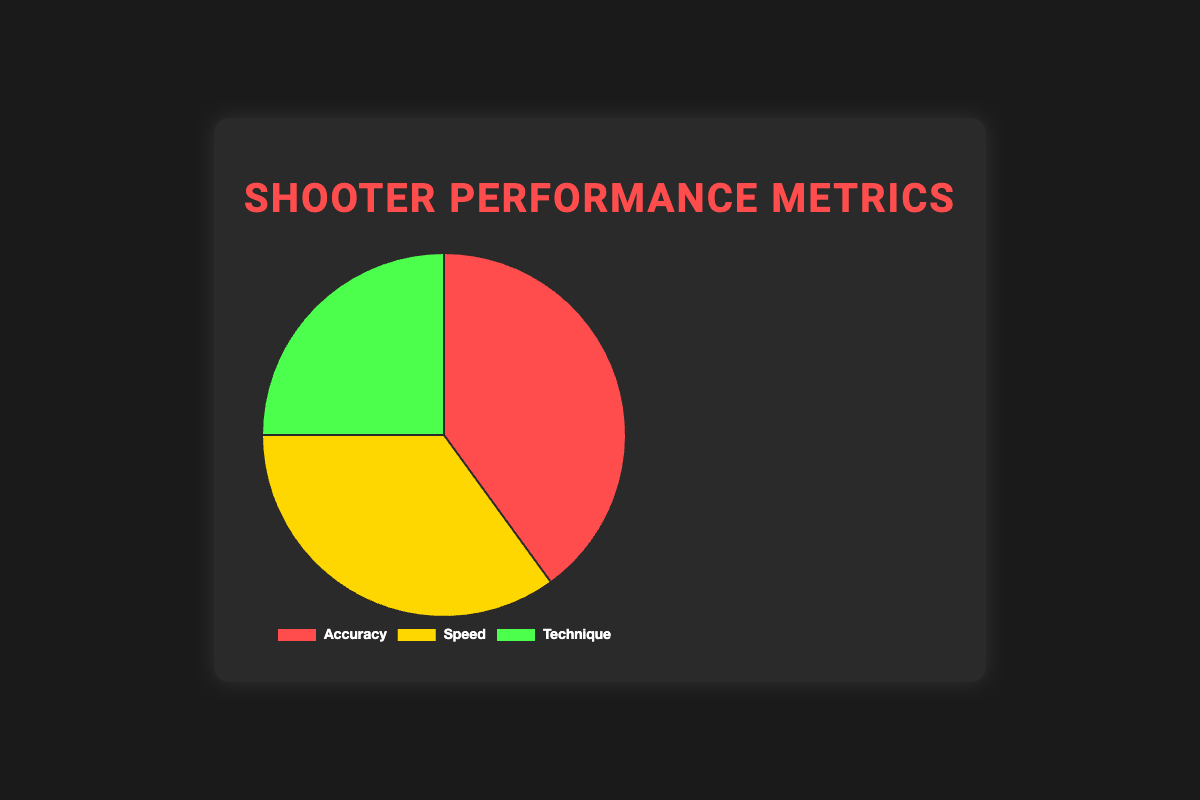Which category has the highest percentage? Look at the values in the pie chart and identify the category with the highest percentage. Accuracy is 40%, Speed is 35%, and Technique is 25%. Accuracy has the highest percentage at 40%.
Answer: Accuracy Which category has the lowest percentage? Look at the values in the pie chart and identify the category with the lowest percentage. Accuracy is 40%, Speed is 35%, and Technique is 25%. Technique has the lowest percentage at 25%.
Answer: Technique What is the total percentage distribution of Accuracy and Speed combined? Add the percentages of Accuracy and Speed. Accuracy is 40%, and Speed is 35%. So, 40% + 35% = 75%.
Answer: 75% How much more is the percentage of Accuracy compared to Technique? Subtract the percentage of Technique from Accuracy. Accuracy is 40% and Technique is 25%. So, 40% - 25% = 15%.
Answer: 15% What is the average percentage of all the categories? Add the percentages of all three categories and then divide by the number of categories (3). Accuracy is 40%, Speed is 35%, and Technique is 25%. (40% + 35% + 25%) / 3 = 33.33%.
Answer: 33.33% Which category is represented by the green color? Look at the colors in the pie chart to find which color corresponds to which category. The green color represents Technique.
Answer: Technique Is there a category with a percentage close to 30%? If yes, which one? Look at the values in the pie chart and identify if any values are close to 30%. Speed is 35%, which is close to 30%.
Answer: Speed How does the percentage of Speed compare to the percentage of Technique? Compare the percentages of Speed and Technique. Speed is 35% and Technique is 25%. So, Speed has a higher percentage than Technique.
Answer: Speed has a higher percentage If we increase the percentage of Technique by 10%, what will be its new percentage? Add 10% to the current percentage of Technique. Technique is 25% initially. So, 25% + 10% = 35%.
Answer: 35% By what percentage does Accuracy exceed Speed? Subtract the percentage of Speed from Accuracy. Accuracy is 40% and Speed is 35%. So, 40% - 35% = 5%.
Answer: 5% 